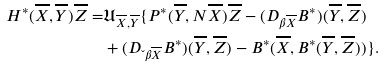<formula> <loc_0><loc_0><loc_500><loc_500>H ^ { * } ( \overline { X } , \overline { Y } ) \overline { Z } = & \mathfrak { U } _ { \overline { X } , \overline { Y } } \{ P ^ { * } ( \overline { Y } , N \overline { X } ) \overline { Z } - ( D _ { \beta \overline { X } } B ^ { * } ) ( \overline { Y } , \overline { Z } ) \\ & + ( D _ { \L \beta \overline { X } } B ^ { * } ) ( \overline { Y } , \overline { Z } ) - B ^ { * } ( \overline { X } , B ^ { * } ( \overline { Y } , \overline { Z } ) ) \} .</formula> 